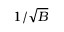Convert formula to latex. <formula><loc_0><loc_0><loc_500><loc_500>1 / \sqrt { B }</formula> 